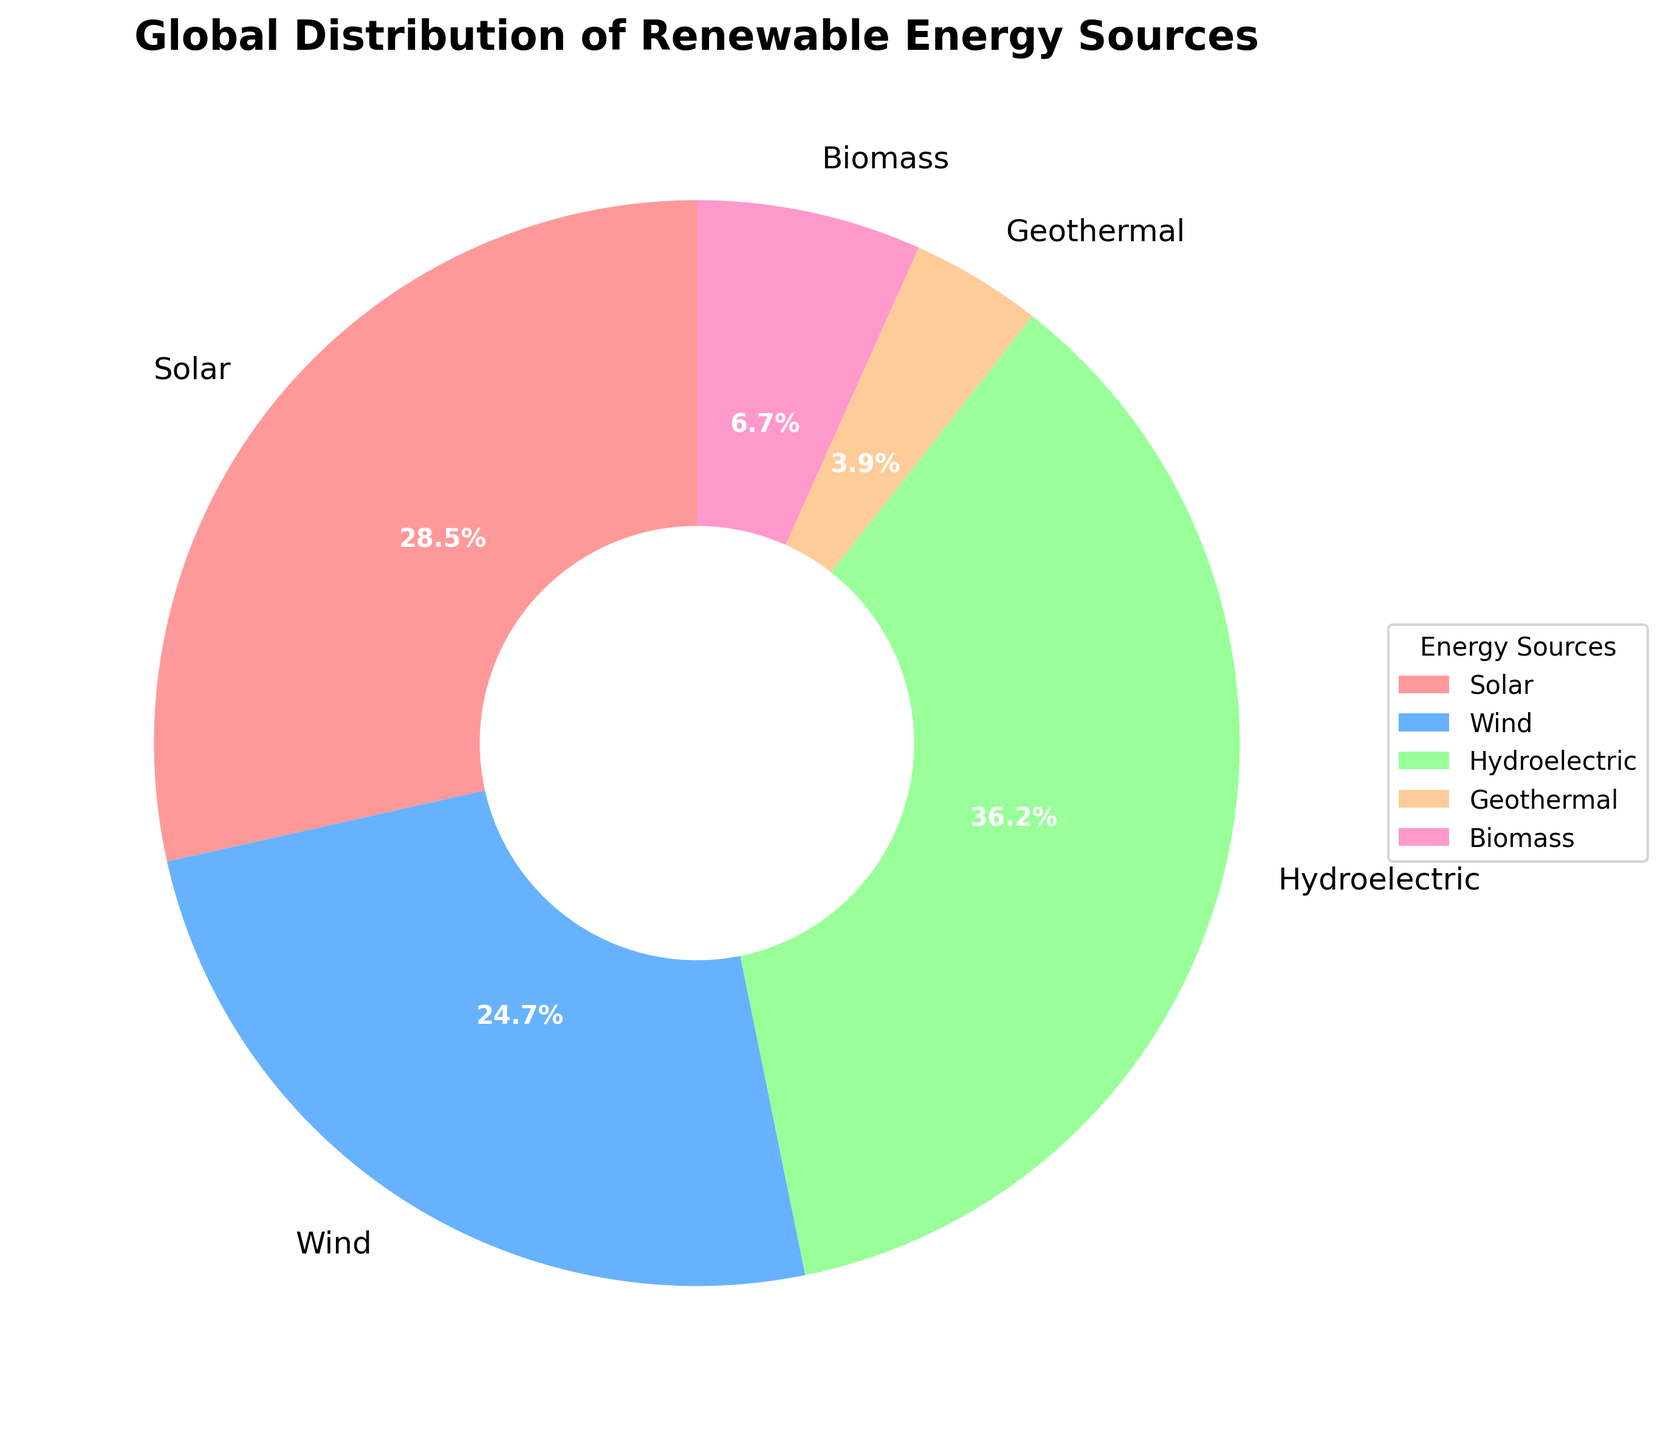Which energy source has the highest percentage in the global distribution? Hydroelectric has the highest percentage among the listed renewable energy sources, as indicated by the largest portion of the pie chart.
Answer: Hydroelectric What is the combined percentage of solar and wind energy sources? To find the combined percentage of solar and wind, sum their individual percentages: Solar (28.5%) + Wind (24.7%) = 53.2%.
Answer: 53.2% Which energy source has the least percentage in the global distribution? The smallest portion of the pie chart represents Geothermal energy at 3.9%.
Answer: Geothermal How much more percentage does hydroelectric energy have compared to biomass? The percentage of hydroelectric energy (36.2%) minus the percentage of biomass (6.7%) equals 29.5%.
Answer: 29.5% What is the difference in percentage between solar and wind energy sources? The percentage of solar energy (28.5%) minus the percentage of wind energy (24.7%) equals 3.8%.
Answer: 3.8% What is the average percentage of all the renewable energy sources listed? To find the average, sum all percentages and divide by the number of sources: (28.5% + 24.7% + 36.2% + 3.9% + 6.7%) / 5 = 20%.
Answer: 20% Is the combined percentage of geothermal and biomass energy sources greater than wind energy? Sum the percentages of geothermal and biomass (3.9% + 6.7% = 10.6%), which is less than wind energy at 24.7%.
Answer: No Which two energy sources combined make up more than half of the total distribution? By examining the pie chart, two sources whose percentages sum to more than 50% are Solar (28.5%) and Hydroelectric (36.2%), which combined total 64.7%.
Answer: Solar and Hydroelectric What is the percentage difference between the highest and lowest energy sources? The highest percentage is Hydroelectric (36.2%) and the lowest is Geothermal (3.9%). Subtracting gives 36.2% - 3.9% = 32.3%.
Answer: 32.3% 